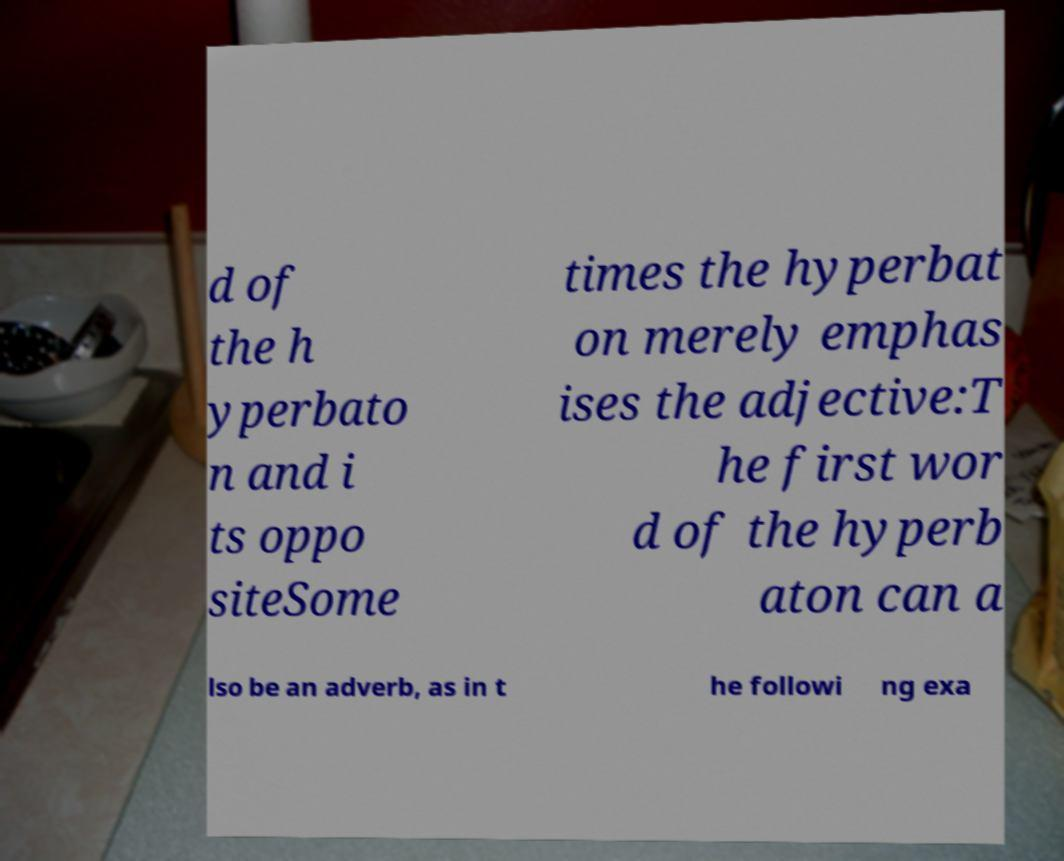For documentation purposes, I need the text within this image transcribed. Could you provide that? d of the h yperbato n and i ts oppo siteSome times the hyperbat on merely emphas ises the adjective:T he first wor d of the hyperb aton can a lso be an adverb, as in t he followi ng exa 